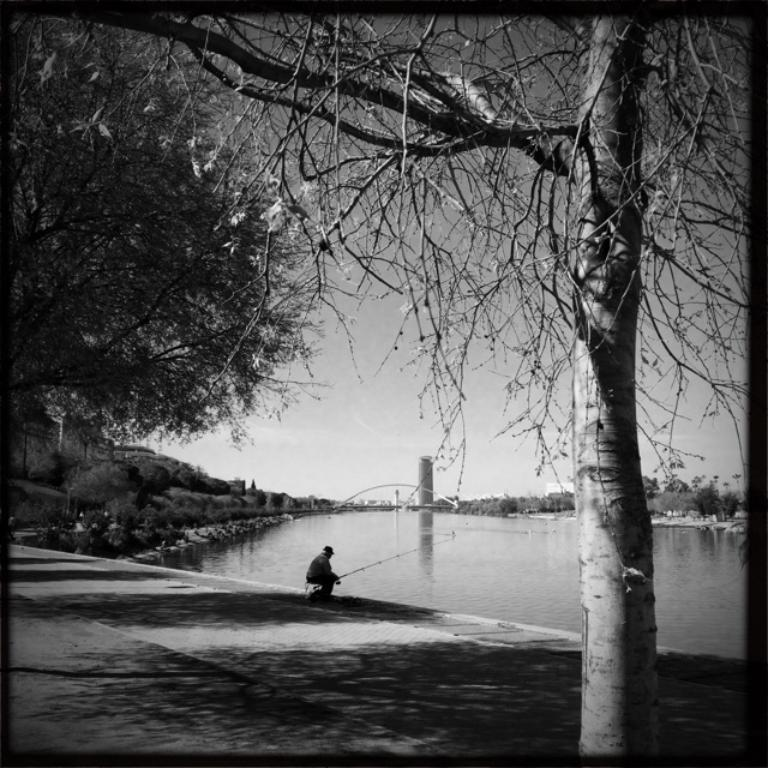What is the color scheme of the image? The image is black and white. Can you describe the main subject in the image? There is a person in the image. What type of natural environment is visible in the image? There are trees, water, and sky visible in the image. What structures can be seen in the distance? There is a bridge and a tower in the distance. What type of lettuce is being used as a bed for the person in the image? There is no lettuce or bed present in the image; it features a person in a black and white environment with trees, water, sky, a bridge, and a tower. Can you describe the wound on the person's arm in the image? There is no wound visible on the person's arm in the image. 